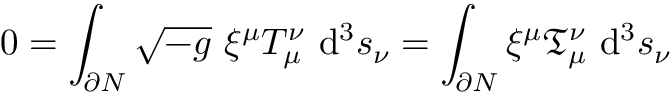<formula> <loc_0><loc_0><loc_500><loc_500>0 = \int _ { \partial N } { \sqrt { - g } } \ \xi ^ { \mu } T _ { \mu } ^ { \nu } \ d ^ { 3 } s _ { \nu } = \int _ { \partial N } \xi ^ { \mu } { \mathfrak { T } } _ { \mu } ^ { \nu } \ d ^ { 3 } s _ { \nu }</formula> 